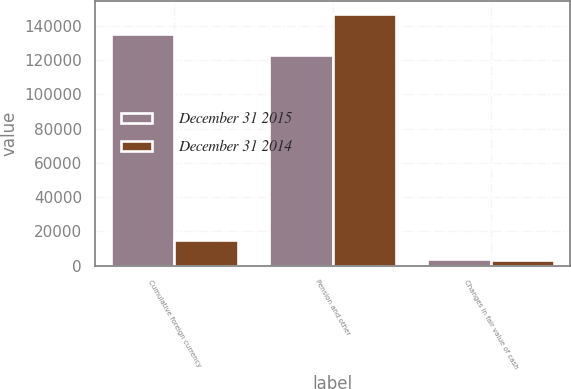<chart> <loc_0><loc_0><loc_500><loc_500><stacked_bar_chart><ecel><fcel>Cumulative foreign currency<fcel>Pension and other<fcel>Changes in fair value of cash<nl><fcel>December 31 2015<fcel>135278<fcel>123301<fcel>4006<nl><fcel>December 31 2014<fcel>14884<fcel>147237<fcel>3190<nl></chart> 